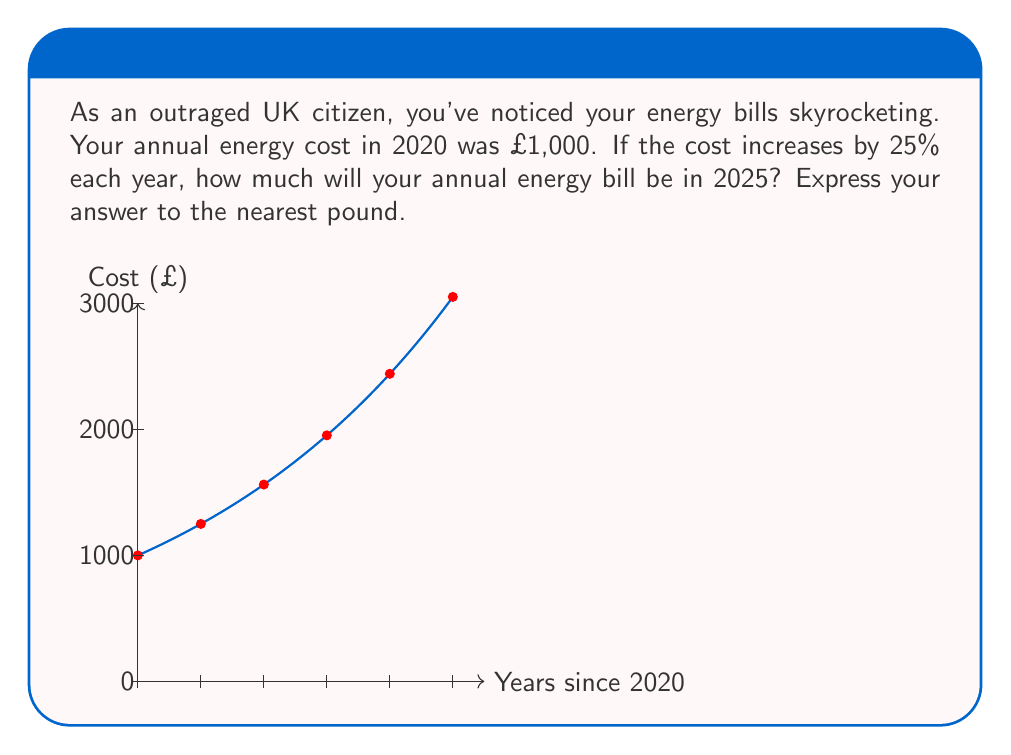Provide a solution to this math problem. Let's approach this step-by-step:

1) We start with an initial cost of £1,000 in 2020.
2) The cost increases by 25% each year, which means we multiply by 1.25 each year.
3) We need to calculate this for 5 years (from 2020 to 2025).

We can express this mathematically as:

$$ \text{Cost in 2025} = 1000 \times (1.25)^5 $$

Let's calculate:

$$ \begin{aligned}
\text{Cost in 2025} &= 1000 \times (1.25)^5 \\
&= 1000 \times 3.0517578125 \\
&= 3051.7578125
\end{aligned} $$

Rounding to the nearest pound, we get £3,052.

This exponential growth explains why you, as an outraged UK citizen, are seeing such dramatic increases in your energy bills!
Answer: £3,052 